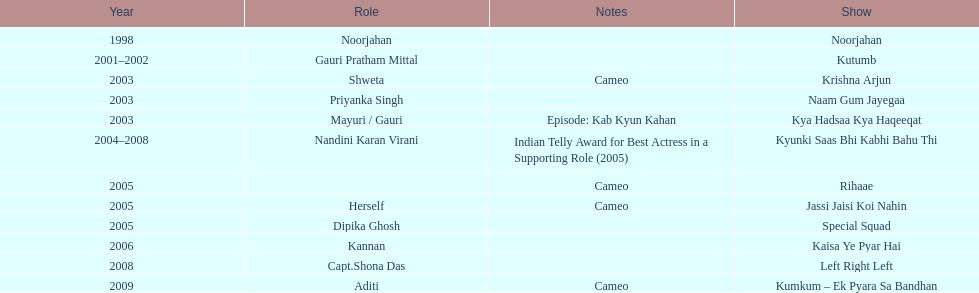Besides rihaae, in what other show did gauri tejwani cameo in 2005? Jassi Jaisi Koi Nahin. 